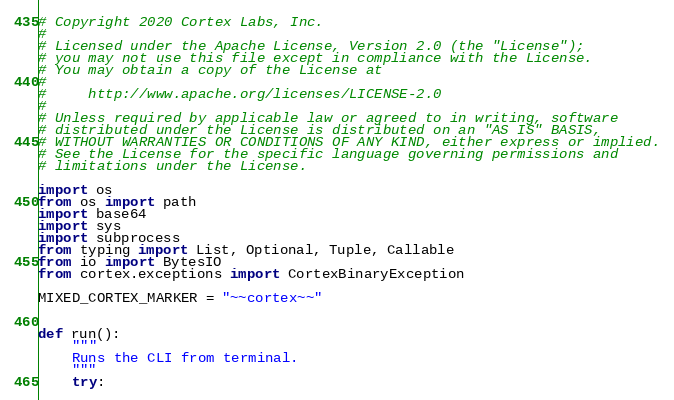Convert code to text. <code><loc_0><loc_0><loc_500><loc_500><_Python_># Copyright 2020 Cortex Labs, Inc.
#
# Licensed under the Apache License, Version 2.0 (the "License");
# you may not use this file except in compliance with the License.
# You may obtain a copy of the License at
#
#     http://www.apache.org/licenses/LICENSE-2.0
#
# Unless required by applicable law or agreed to in writing, software
# distributed under the License is distributed on an "AS IS" BASIS,
# WITHOUT WARRANTIES OR CONDITIONS OF ANY KIND, either express or implied.
# See the License for the specific language governing permissions and
# limitations under the License.

import os
from os import path
import base64
import sys
import subprocess
from typing import List, Optional, Tuple, Callable
from io import BytesIO
from cortex.exceptions import CortexBinaryException

MIXED_CORTEX_MARKER = "~~cortex~~"


def run():
    """
    Runs the CLI from terminal.
    """
    try:</code> 